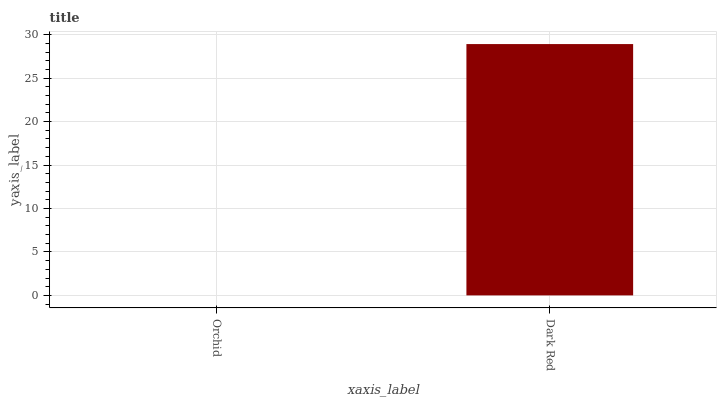Is Orchid the minimum?
Answer yes or no. Yes. Is Dark Red the maximum?
Answer yes or no. Yes. Is Dark Red the minimum?
Answer yes or no. No. Is Dark Red greater than Orchid?
Answer yes or no. Yes. Is Orchid less than Dark Red?
Answer yes or no. Yes. Is Orchid greater than Dark Red?
Answer yes or no. No. Is Dark Red less than Orchid?
Answer yes or no. No. Is Dark Red the high median?
Answer yes or no. Yes. Is Orchid the low median?
Answer yes or no. Yes. Is Orchid the high median?
Answer yes or no. No. Is Dark Red the low median?
Answer yes or no. No. 